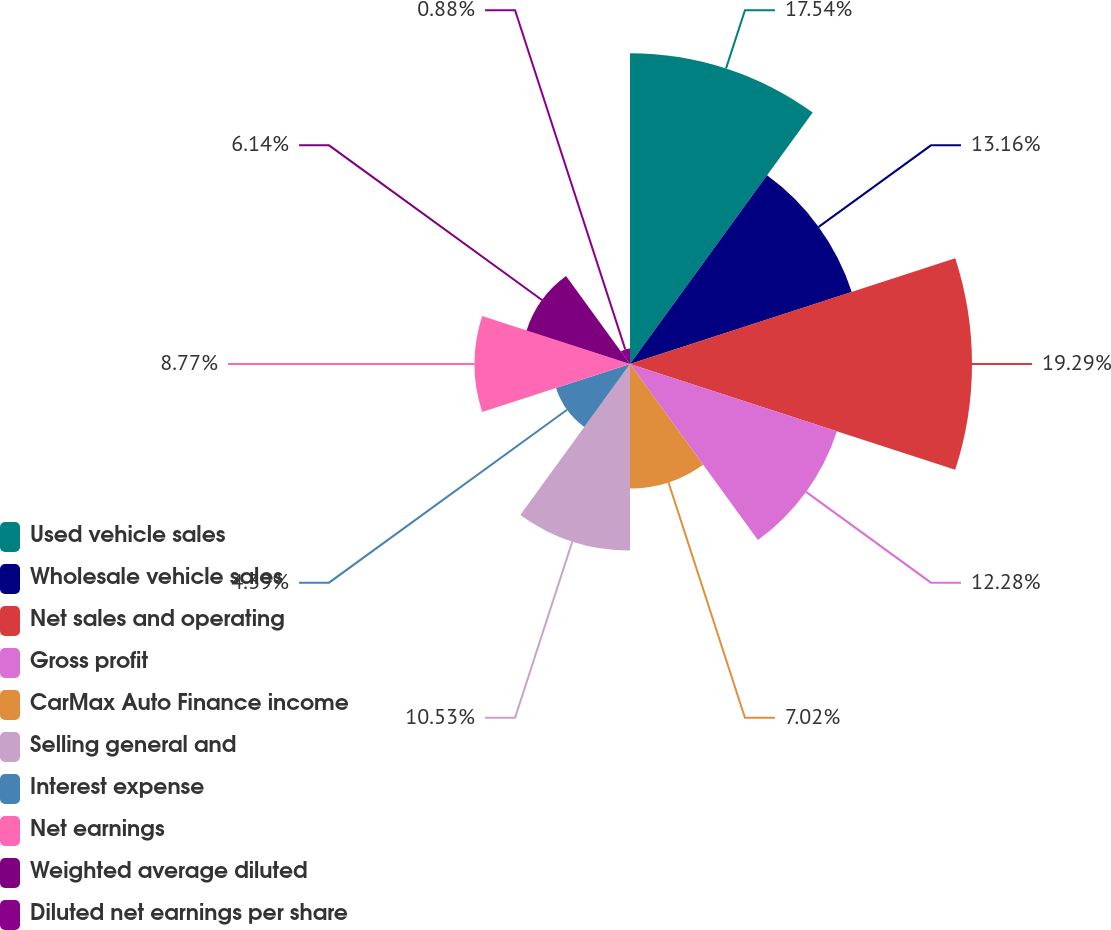<chart> <loc_0><loc_0><loc_500><loc_500><pie_chart><fcel>Used vehicle sales<fcel>Wholesale vehicle sales<fcel>Net sales and operating<fcel>Gross profit<fcel>CarMax Auto Finance income<fcel>Selling general and<fcel>Interest expense<fcel>Net earnings<fcel>Weighted average diluted<fcel>Diluted net earnings per share<nl><fcel>17.54%<fcel>13.16%<fcel>19.3%<fcel>12.28%<fcel>7.02%<fcel>10.53%<fcel>4.39%<fcel>8.77%<fcel>6.14%<fcel>0.88%<nl></chart> 